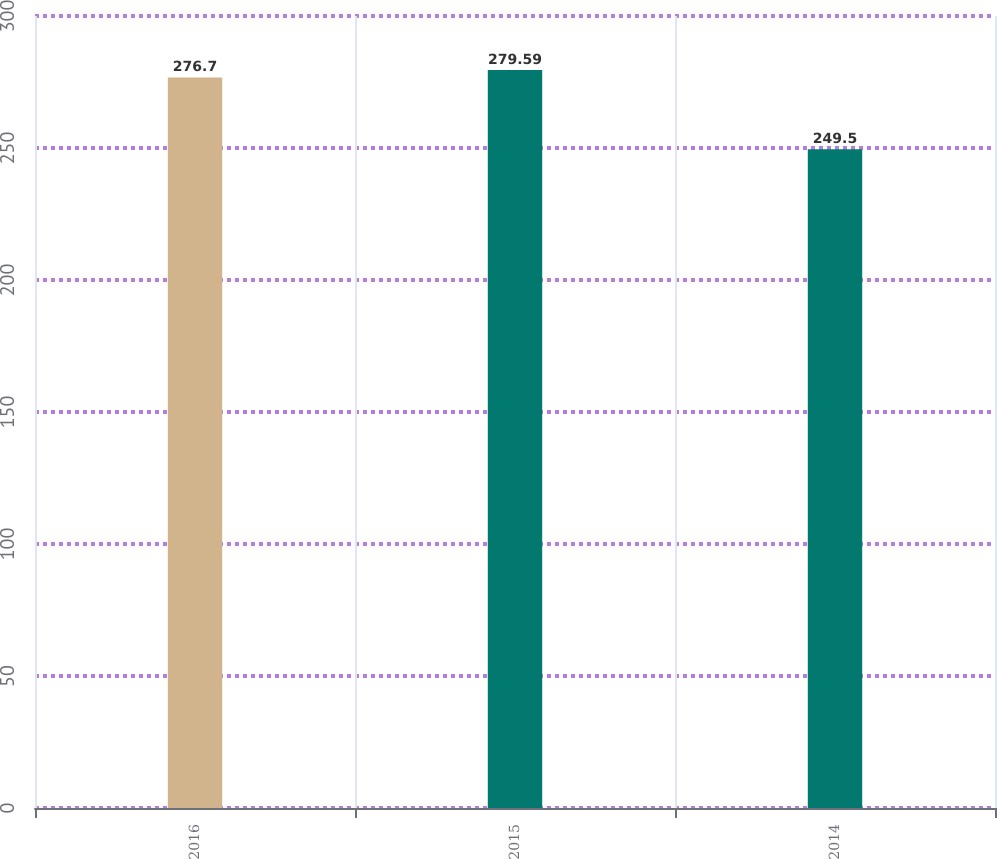<chart> <loc_0><loc_0><loc_500><loc_500><bar_chart><fcel>2016<fcel>2015<fcel>2014<nl><fcel>276.7<fcel>279.59<fcel>249.5<nl></chart> 